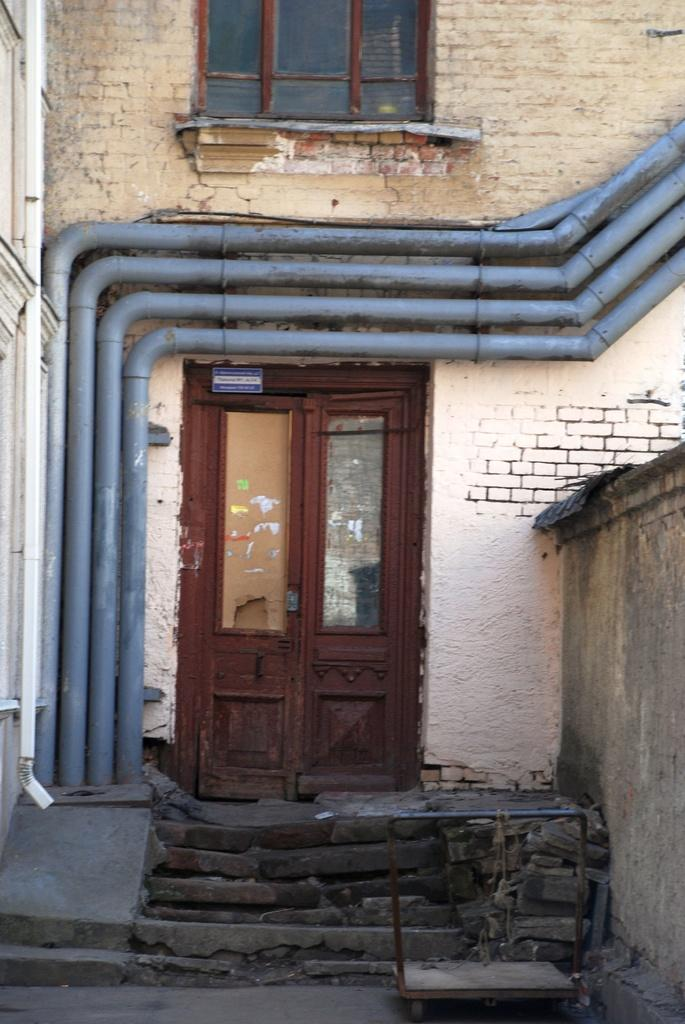What type of structure can be seen in the image? There is a wall and a door in the image. What is the material of the wall in the background? The wall in the background is a brick wall. Are there any openings in the brick wall? Yes, there are glass windows in the brick wall. How many laborers are visible working on the wall in the image? There are no laborers visible in the image; it only shows a wall, a door, and a brick wall with glass windows. What type of balance is required to fly the planes seen in the image? There are no planes visible in the image, so the question of balance is not applicable. 